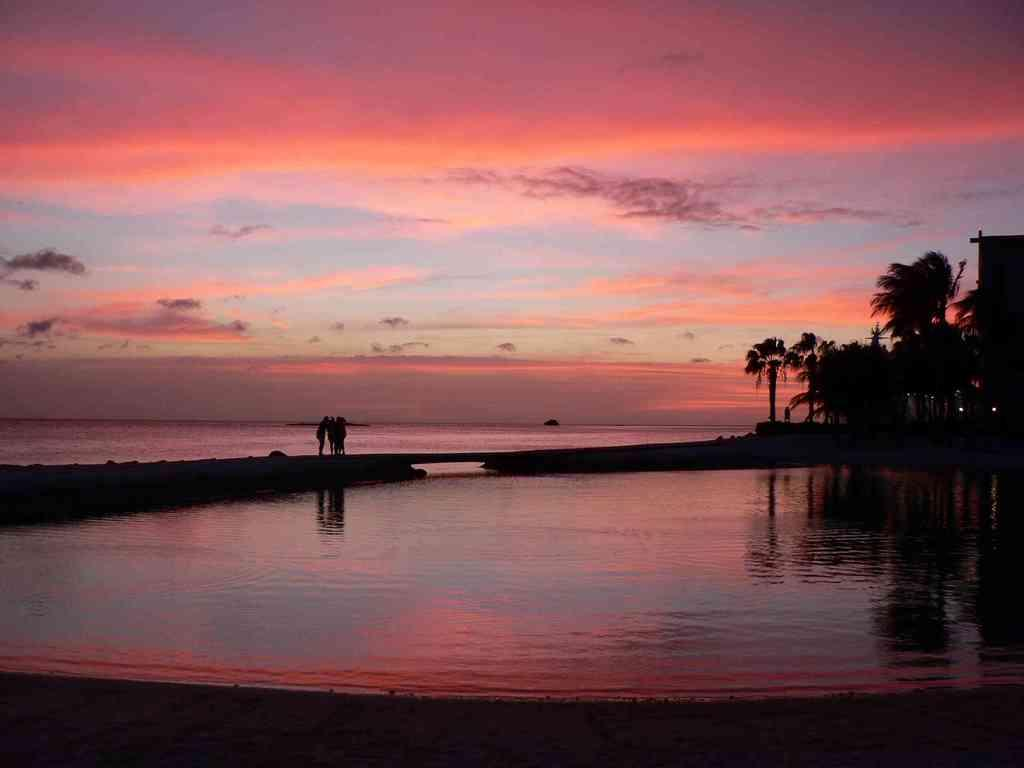What is the main feature of the image? The main feature of the image is a water surface. Are there any people present in the image? Yes, there are people standing in the image. What type of vegetation can be seen on the right side of the image? There are trees on the right side of the image. What is visible in the sky at the top of the image? There are clouds visible in the sky at the top of the image. Can you see any goats wearing water rings in the image? No, there are no goats or water rings present in the image. 